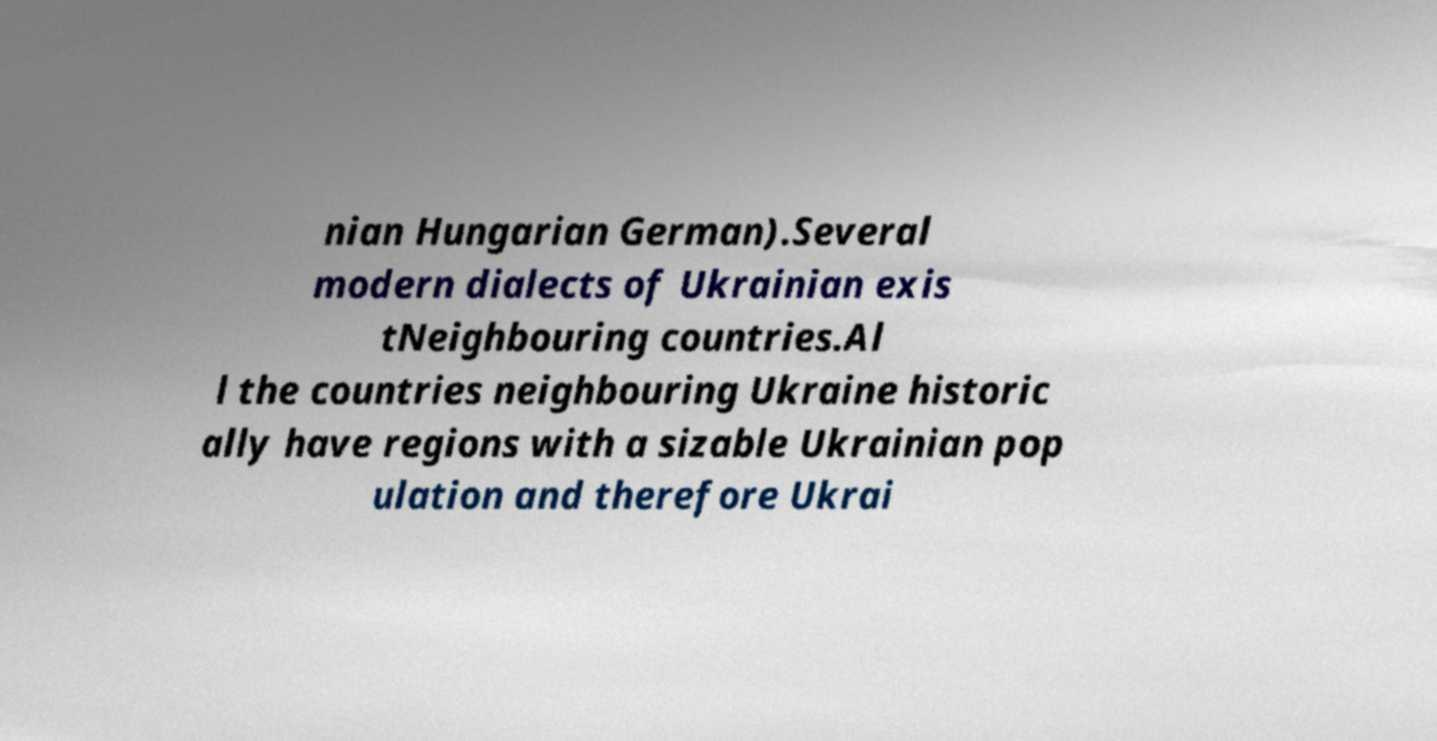I need the written content from this picture converted into text. Can you do that? nian Hungarian German).Several modern dialects of Ukrainian exis tNeighbouring countries.Al l the countries neighbouring Ukraine historic ally have regions with a sizable Ukrainian pop ulation and therefore Ukrai 